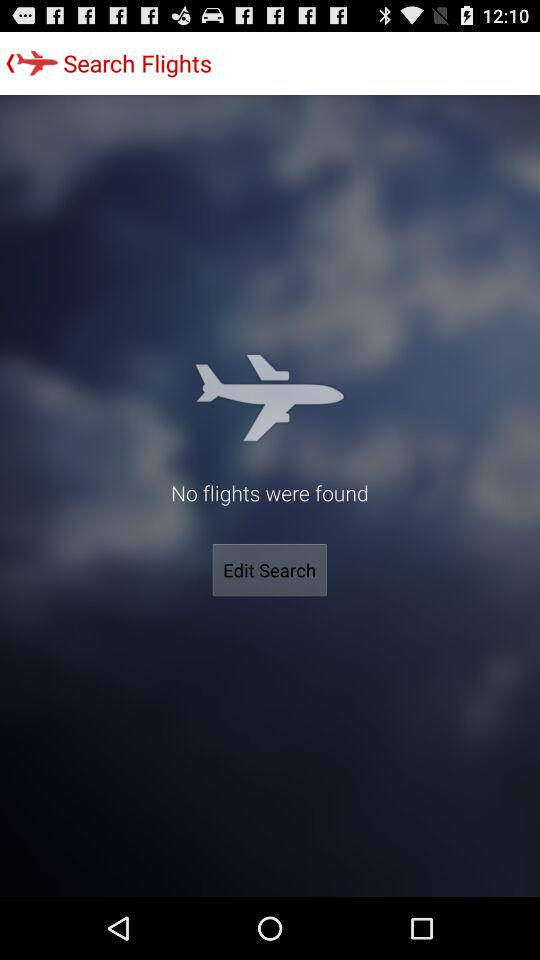Is there any flight found? There were no flights found. 